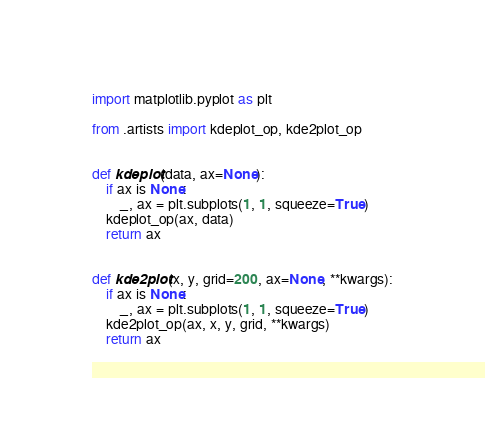Convert code to text. <code><loc_0><loc_0><loc_500><loc_500><_Python_>import matplotlib.pyplot as plt

from .artists import kdeplot_op, kde2plot_op


def kdeplot(data, ax=None):
    if ax is None:
        _, ax = plt.subplots(1, 1, squeeze=True)
    kdeplot_op(ax, data)
    return ax


def kde2plot(x, y, grid=200, ax=None, **kwargs):
    if ax is None:
        _, ax = plt.subplots(1, 1, squeeze=True)
    kde2plot_op(ax, x, y, grid, **kwargs)
    return ax
</code> 